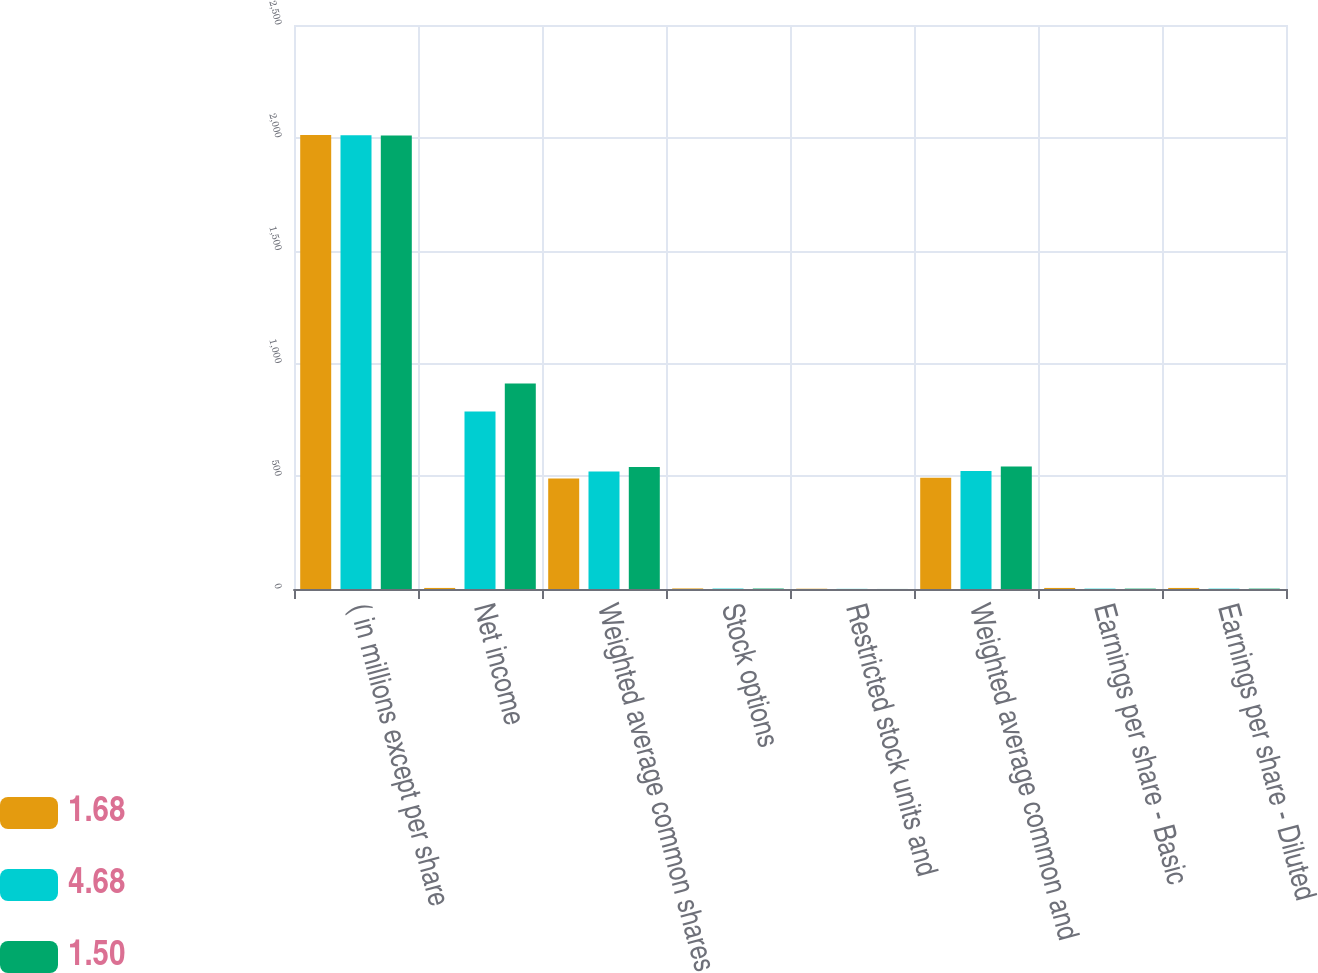Convert chart to OTSL. <chart><loc_0><loc_0><loc_500><loc_500><stacked_bar_chart><ecel><fcel>( in millions except per share<fcel>Net income<fcel>Weighted average common shares<fcel>Stock options<fcel>Restricted stock units and<fcel>Weighted average common and<fcel>Earnings per share - Basic<fcel>Earnings per share - Diluted<nl><fcel>1.68<fcel>2012<fcel>4.71<fcel>489.4<fcel>2.4<fcel>1.2<fcel>493<fcel>4.71<fcel>4.68<nl><fcel>4.68<fcel>2011<fcel>787<fcel>520.7<fcel>1.8<fcel>0.6<fcel>523.1<fcel>1.51<fcel>1.5<nl><fcel>1.5<fcel>2010<fcel>911<fcel>540.3<fcel>2<fcel>0.2<fcel>542.5<fcel>1.69<fcel>1.68<nl></chart> 